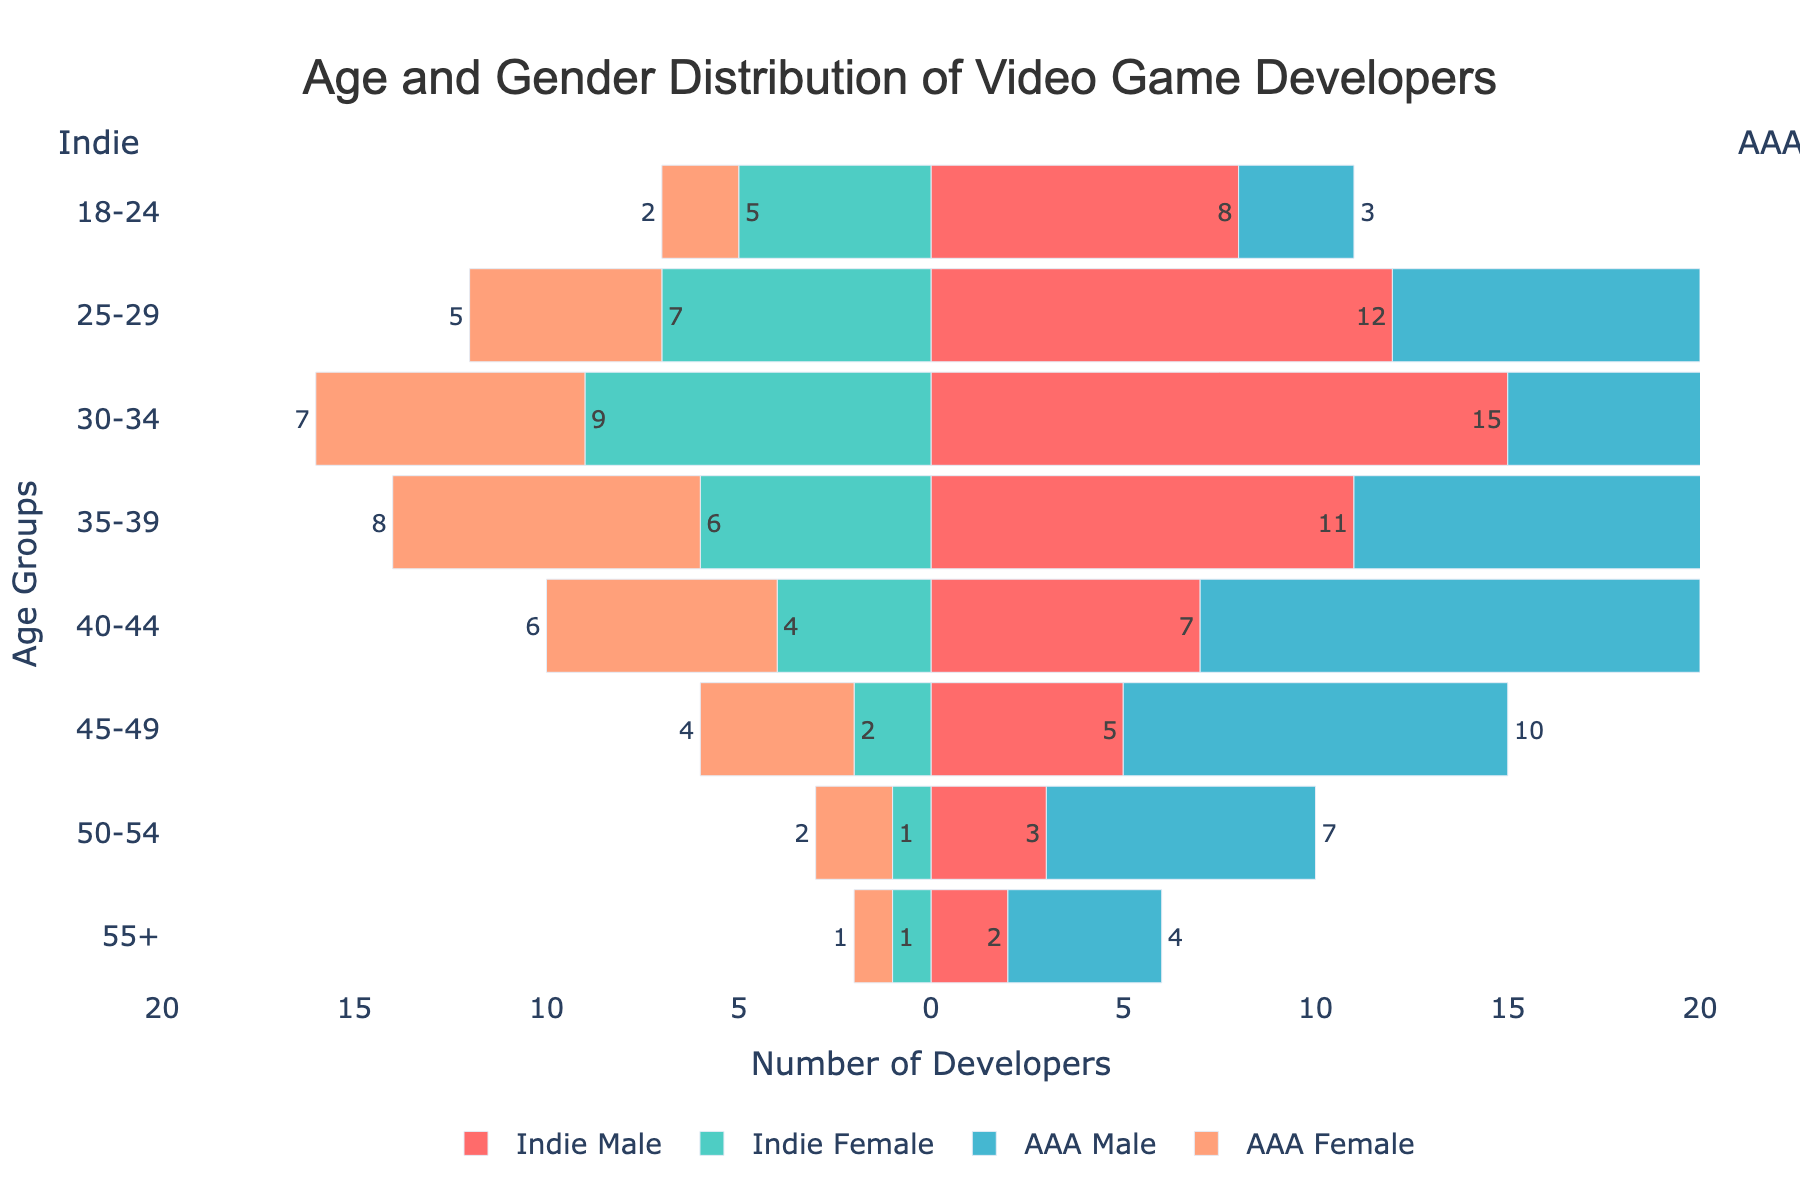What is the title of the figure? The title of the figure is found at the top center of the graph.
Answer: Age and Gender Distribution of Video Game Developers What is the highest number of AAA Male developers in any age group? By examining the AAA Male bars, the highest number is the one that extends the furthest to the right among all age groups.
Answer: 15 How many Indie Female developers are there in the 25-29 age group? Look for the 25-29 age group and check the length of the Indie Female bar crafted with a negative value on the x-axis.
Answer: 7 What age group has the highest total number of video game developers (all categories combined)? Add the number of developers in each category for every age group and compare the totals. The 30-34 age group has 15 (Indie Male) + 9 (Indie Female) + 12 (AAA Male) + 7 (AAA Female) = 43 developers.
Answer: 30-34 In which age group do AAA companies have more female developers than indie studios? Compare the AAA Female and Indie Female values for each age group to determine where AAA has larger values. The comparison shows that in age groups 35-39, 40-44, and 45-49, AAA companies have more female developers than indie studios.
Answer: 35-39, 40-44, 45-49 Between indie studios and AAA companies, which has a higher number of developers aged 50-54? Sum indie studio's values and AAA company's values for the 50-54 age group. Indie studios have 3 (Male) + 1 (Female) = 4 developers while AAA companies have 7 (Male) + 2 (Female) = 9 developers.
Answer: AAA companies What is the difference in the number of Indie Male and AAA Male developers in the 40-44 age group? Subtract the number of AAA Male developers from the number of Indie Male developers in the 40-44 age group: 7 - 13 = -6.
Answer: -6 Which group has the smallest representation in the 25-29 age group? Identify the group category with the shortest bar in the 25-29 age group. The Indie Female category is the smallest with 5 developers.
Answer: Indie Female How does the number of Indie Male developers in the 30-34 age group compare to the number of AAA Male developers in the same age group? Compare the lengths of the bars for the Indie Male (15) and AAA Male (12) developers in the 30-34 age group.
Answer: Indie Male is higher Is there any age group where the number of female developers (both Indie and AAA combined) is equal? Check for age groups where the combined values of Indie Female and AAA Female equal. No age group has an equal number of female developers.
Answer: No 